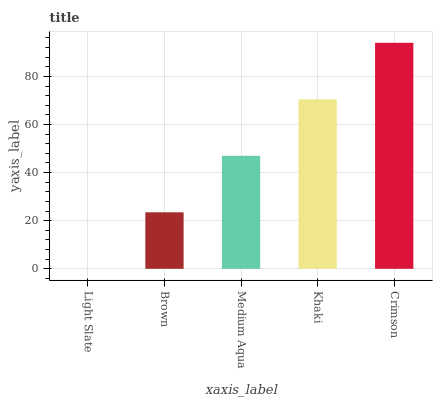Is Light Slate the minimum?
Answer yes or no. Yes. Is Crimson the maximum?
Answer yes or no. Yes. Is Brown the minimum?
Answer yes or no. No. Is Brown the maximum?
Answer yes or no. No. Is Brown greater than Light Slate?
Answer yes or no. Yes. Is Light Slate less than Brown?
Answer yes or no. Yes. Is Light Slate greater than Brown?
Answer yes or no. No. Is Brown less than Light Slate?
Answer yes or no. No. Is Medium Aqua the high median?
Answer yes or no. Yes. Is Medium Aqua the low median?
Answer yes or no. Yes. Is Crimson the high median?
Answer yes or no. No. Is Light Slate the low median?
Answer yes or no. No. 